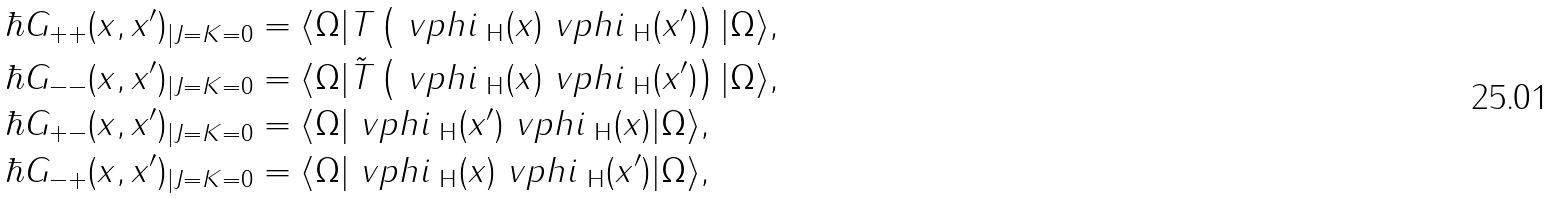<formula> <loc_0><loc_0><loc_500><loc_500>\hbar { G } _ { + + } ( x , x ^ { \prime } ) _ { | J = K = 0 } & = \langle \Omega | T \left ( \ v p h i _ { \text { H} } ( x ) \ v p h i _ { \text { H} } ( x ^ { \prime } ) \right ) | \Omega \rangle , \\ \hbar { G } _ { - - } ( x , x ^ { \prime } ) _ { | J = K = 0 } & = \langle \Omega | \tilde { T } \left ( \ v p h i _ { \text { H} } ( x ) \ v p h i _ { \text { H} } ( x ^ { \prime } ) \right ) | \Omega \rangle , \\ \hbar { G } _ { + - } ( x , x ^ { \prime } ) _ { | J = K = 0 } & = \langle \Omega | \ v p h i _ { \text { H} } ( x ^ { \prime } ) \ v p h i _ { \text { H} } ( x ) | \Omega \rangle , \\ \hbar { G } _ { - + } ( x , x ^ { \prime } ) _ { | J = K = 0 } & = \langle \Omega | \ v p h i _ { \text { H} } ( x ) \ v p h i _ { \text { H} } ( x ^ { \prime } ) | \Omega \rangle ,</formula> 